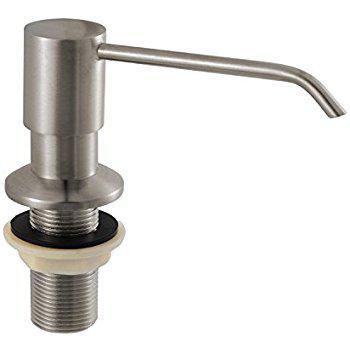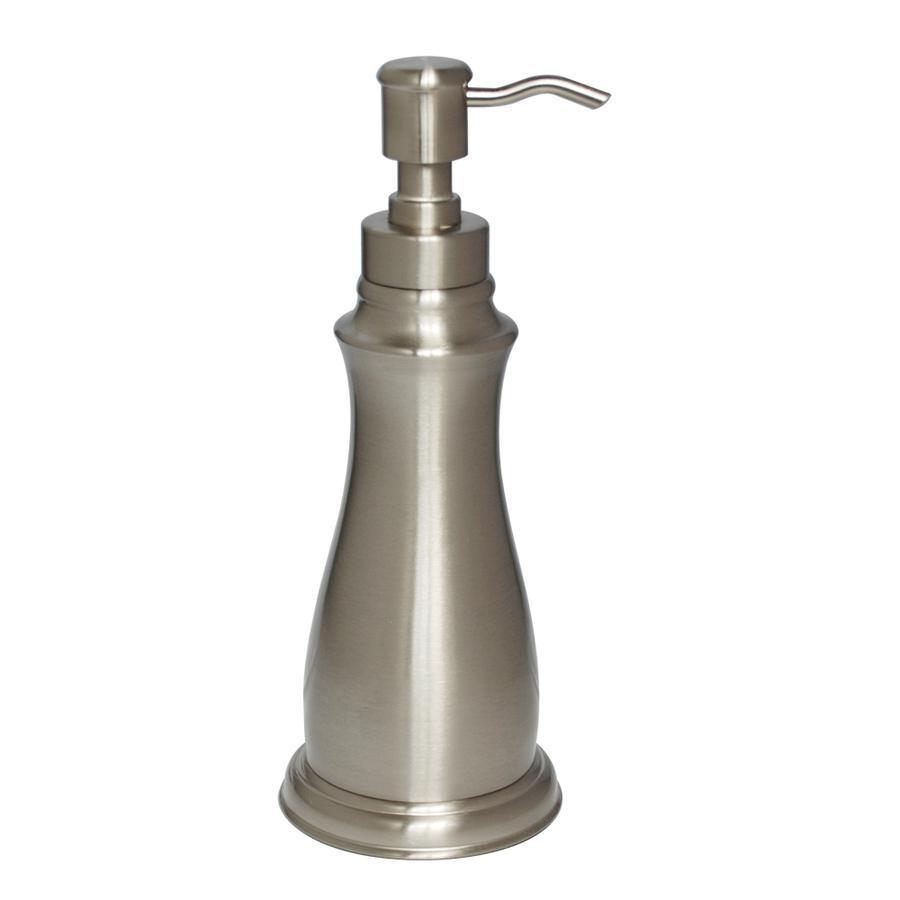The first image is the image on the left, the second image is the image on the right. Evaluate the accuracy of this statement regarding the images: "There is a silver colored dispenser in the right image.". Is it true? Answer yes or no. Yes. The first image is the image on the left, the second image is the image on the right. Considering the images on both sides, is "The pump on the left is not connected to a container." valid? Answer yes or no. Yes. 